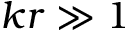<formula> <loc_0><loc_0><loc_500><loc_500>k r \gg 1</formula> 